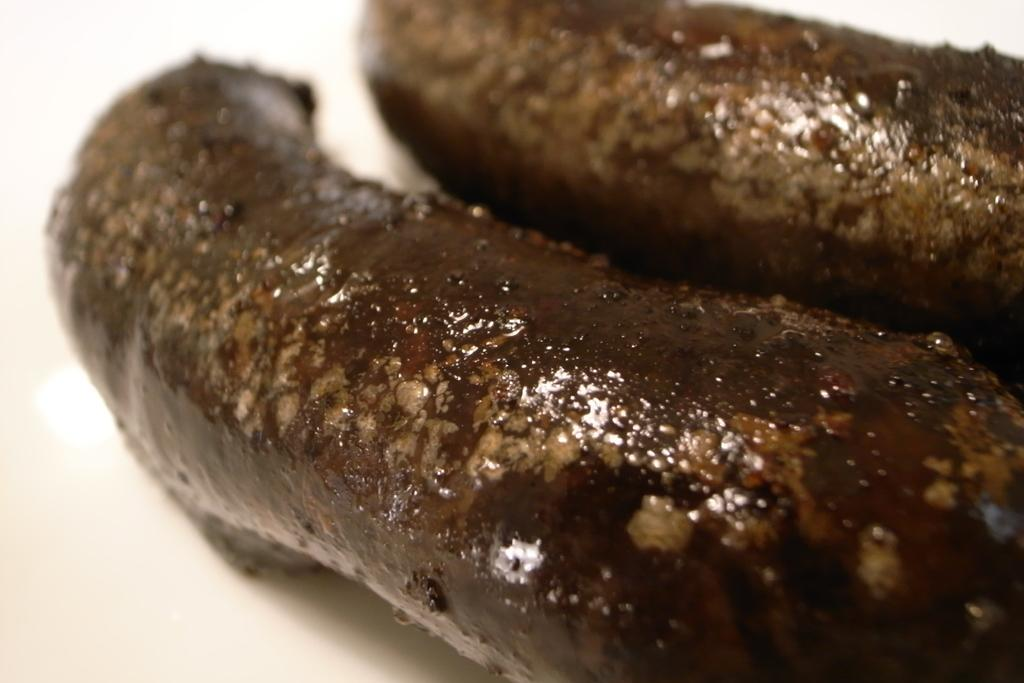What is the primary color of the surface in the image? The surface in the image is white colored. How many objects are present on the white colored surface? There are two objects on the white colored surface. What colors are the objects on the white colored surface? The objects are brown and cream in color. What type of tool is the tramp using to make the discovery in the image? There is no tramp or tool present in the image, and no discovery is being made. 